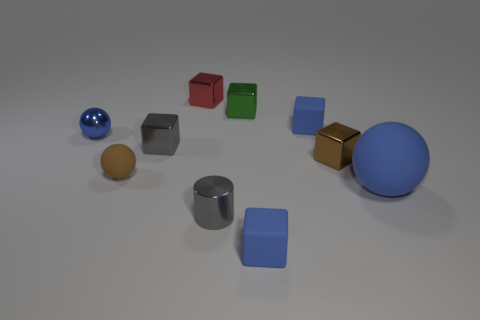Subtract all blue matte blocks. How many blocks are left? 4 Subtract all green balls. How many blue blocks are left? 2 Subtract all brown blocks. How many blocks are left? 5 Subtract 1 spheres. How many spheres are left? 2 Subtract 1 green blocks. How many objects are left? 9 Subtract all cylinders. How many objects are left? 9 Subtract all blue cylinders. Subtract all green balls. How many cylinders are left? 1 Subtract all tiny purple metal spheres. Subtract all blue cubes. How many objects are left? 8 Add 4 tiny brown shiny objects. How many tiny brown shiny objects are left? 5 Add 7 large red metallic cylinders. How many large red metallic cylinders exist? 7 